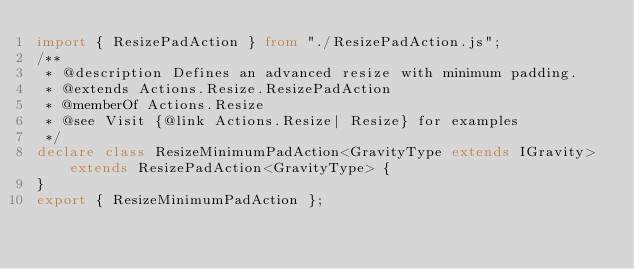Convert code to text. <code><loc_0><loc_0><loc_500><loc_500><_TypeScript_>import { ResizePadAction } from "./ResizePadAction.js";
/**
 * @description Defines an advanced resize with minimum padding.
 * @extends Actions.Resize.ResizePadAction
 * @memberOf Actions.Resize
 * @see Visit {@link Actions.Resize| Resize} for examples
 */
declare class ResizeMinimumPadAction<GravityType extends IGravity> extends ResizePadAction<GravityType> {
}
export { ResizeMinimumPadAction };
</code> 